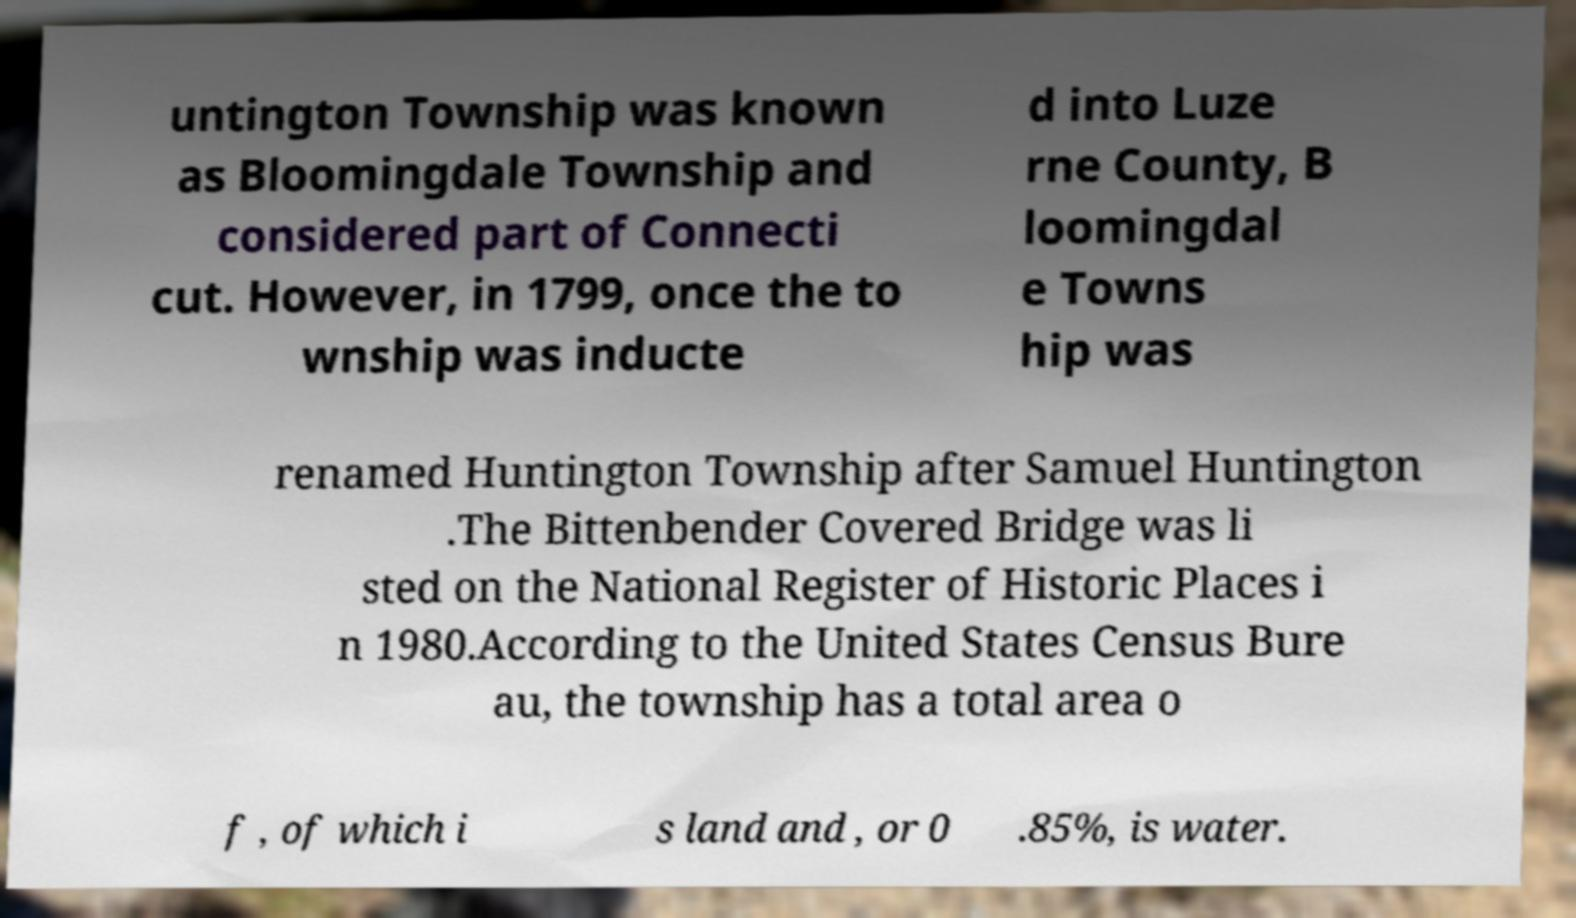Could you extract and type out the text from this image? untington Township was known as Bloomingdale Township and considered part of Connecti cut. However, in 1799, once the to wnship was inducte d into Luze rne County, B loomingdal e Towns hip was renamed Huntington Township after Samuel Huntington .The Bittenbender Covered Bridge was li sted on the National Register of Historic Places i n 1980.According to the United States Census Bure au, the township has a total area o f , of which i s land and , or 0 .85%, is water. 